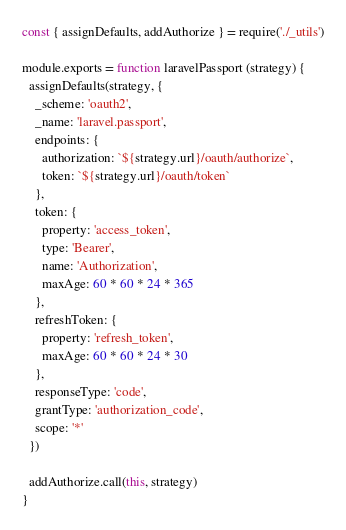<code> <loc_0><loc_0><loc_500><loc_500><_JavaScript_>const { assignDefaults, addAuthorize } = require('./_utils')

module.exports = function laravelPassport (strategy) {
  assignDefaults(strategy, {
    _scheme: 'oauth2',
    _name: 'laravel.passport',
    endpoints: {
      authorization: `${strategy.url}/oauth/authorize`,
      token: `${strategy.url}/oauth/token`
    },
    token: {
      property: 'access_token',
      type: 'Bearer',
      name: 'Authorization',
      maxAge: 60 * 60 * 24 * 365
    },
    refreshToken: {
      property: 'refresh_token',
      maxAge: 60 * 60 * 24 * 30
    },
    responseType: 'code',
    grantType: 'authorization_code',
    scope: '*'
  })

  addAuthorize.call(this, strategy)
}
</code> 